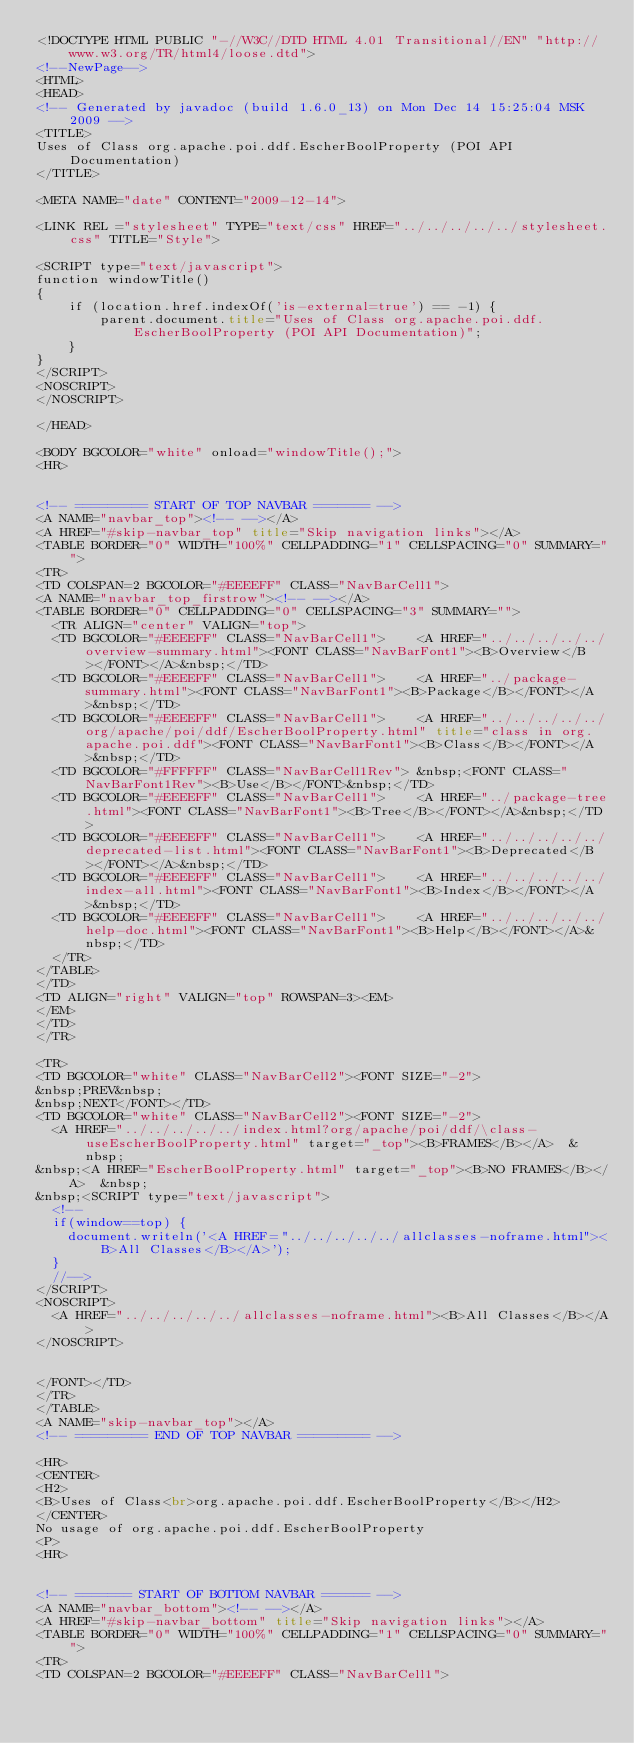<code> <loc_0><loc_0><loc_500><loc_500><_HTML_><!DOCTYPE HTML PUBLIC "-//W3C//DTD HTML 4.01 Transitional//EN" "http://www.w3.org/TR/html4/loose.dtd">
<!--NewPage-->
<HTML>
<HEAD>
<!-- Generated by javadoc (build 1.6.0_13) on Mon Dec 14 15:25:04 MSK 2009 -->
<TITLE>
Uses of Class org.apache.poi.ddf.EscherBoolProperty (POI API Documentation)
</TITLE>

<META NAME="date" CONTENT="2009-12-14">

<LINK REL ="stylesheet" TYPE="text/css" HREF="../../../../../stylesheet.css" TITLE="Style">

<SCRIPT type="text/javascript">
function windowTitle()
{
    if (location.href.indexOf('is-external=true') == -1) {
        parent.document.title="Uses of Class org.apache.poi.ddf.EscherBoolProperty (POI API Documentation)";
    }
}
</SCRIPT>
<NOSCRIPT>
</NOSCRIPT>

</HEAD>

<BODY BGCOLOR="white" onload="windowTitle();">
<HR>


<!-- ========= START OF TOP NAVBAR ======= -->
<A NAME="navbar_top"><!-- --></A>
<A HREF="#skip-navbar_top" title="Skip navigation links"></A>
<TABLE BORDER="0" WIDTH="100%" CELLPADDING="1" CELLSPACING="0" SUMMARY="">
<TR>
<TD COLSPAN=2 BGCOLOR="#EEEEFF" CLASS="NavBarCell1">
<A NAME="navbar_top_firstrow"><!-- --></A>
<TABLE BORDER="0" CELLPADDING="0" CELLSPACING="3" SUMMARY="">
  <TR ALIGN="center" VALIGN="top">
  <TD BGCOLOR="#EEEEFF" CLASS="NavBarCell1">    <A HREF="../../../../../overview-summary.html"><FONT CLASS="NavBarFont1"><B>Overview</B></FONT></A>&nbsp;</TD>
  <TD BGCOLOR="#EEEEFF" CLASS="NavBarCell1">    <A HREF="../package-summary.html"><FONT CLASS="NavBarFont1"><B>Package</B></FONT></A>&nbsp;</TD>
  <TD BGCOLOR="#EEEEFF" CLASS="NavBarCell1">    <A HREF="../../../../../org/apache/poi/ddf/EscherBoolProperty.html" title="class in org.apache.poi.ddf"><FONT CLASS="NavBarFont1"><B>Class</B></FONT></A>&nbsp;</TD>
  <TD BGCOLOR="#FFFFFF" CLASS="NavBarCell1Rev"> &nbsp;<FONT CLASS="NavBarFont1Rev"><B>Use</B></FONT>&nbsp;</TD>
  <TD BGCOLOR="#EEEEFF" CLASS="NavBarCell1">    <A HREF="../package-tree.html"><FONT CLASS="NavBarFont1"><B>Tree</B></FONT></A>&nbsp;</TD>
  <TD BGCOLOR="#EEEEFF" CLASS="NavBarCell1">    <A HREF="../../../../../deprecated-list.html"><FONT CLASS="NavBarFont1"><B>Deprecated</B></FONT></A>&nbsp;</TD>
  <TD BGCOLOR="#EEEEFF" CLASS="NavBarCell1">    <A HREF="../../../../../index-all.html"><FONT CLASS="NavBarFont1"><B>Index</B></FONT></A>&nbsp;</TD>
  <TD BGCOLOR="#EEEEFF" CLASS="NavBarCell1">    <A HREF="../../../../../help-doc.html"><FONT CLASS="NavBarFont1"><B>Help</B></FONT></A>&nbsp;</TD>
  </TR>
</TABLE>
</TD>
<TD ALIGN="right" VALIGN="top" ROWSPAN=3><EM>
</EM>
</TD>
</TR>

<TR>
<TD BGCOLOR="white" CLASS="NavBarCell2"><FONT SIZE="-2">
&nbsp;PREV&nbsp;
&nbsp;NEXT</FONT></TD>
<TD BGCOLOR="white" CLASS="NavBarCell2"><FONT SIZE="-2">
  <A HREF="../../../../../index.html?org/apache/poi/ddf/\class-useEscherBoolProperty.html" target="_top"><B>FRAMES</B></A>  &nbsp;
&nbsp;<A HREF="EscherBoolProperty.html" target="_top"><B>NO FRAMES</B></A>  &nbsp;
&nbsp;<SCRIPT type="text/javascript">
  <!--
  if(window==top) {
    document.writeln('<A HREF="../../../../../allclasses-noframe.html"><B>All Classes</B></A>');
  }
  //-->
</SCRIPT>
<NOSCRIPT>
  <A HREF="../../../../../allclasses-noframe.html"><B>All Classes</B></A>
</NOSCRIPT>


</FONT></TD>
</TR>
</TABLE>
<A NAME="skip-navbar_top"></A>
<!-- ========= END OF TOP NAVBAR ========= -->

<HR>
<CENTER>
<H2>
<B>Uses of Class<br>org.apache.poi.ddf.EscherBoolProperty</B></H2>
</CENTER>
No usage of org.apache.poi.ddf.EscherBoolProperty
<P>
<HR>


<!-- ======= START OF BOTTOM NAVBAR ====== -->
<A NAME="navbar_bottom"><!-- --></A>
<A HREF="#skip-navbar_bottom" title="Skip navigation links"></A>
<TABLE BORDER="0" WIDTH="100%" CELLPADDING="1" CELLSPACING="0" SUMMARY="">
<TR>
<TD COLSPAN=2 BGCOLOR="#EEEEFF" CLASS="NavBarCell1"></code> 